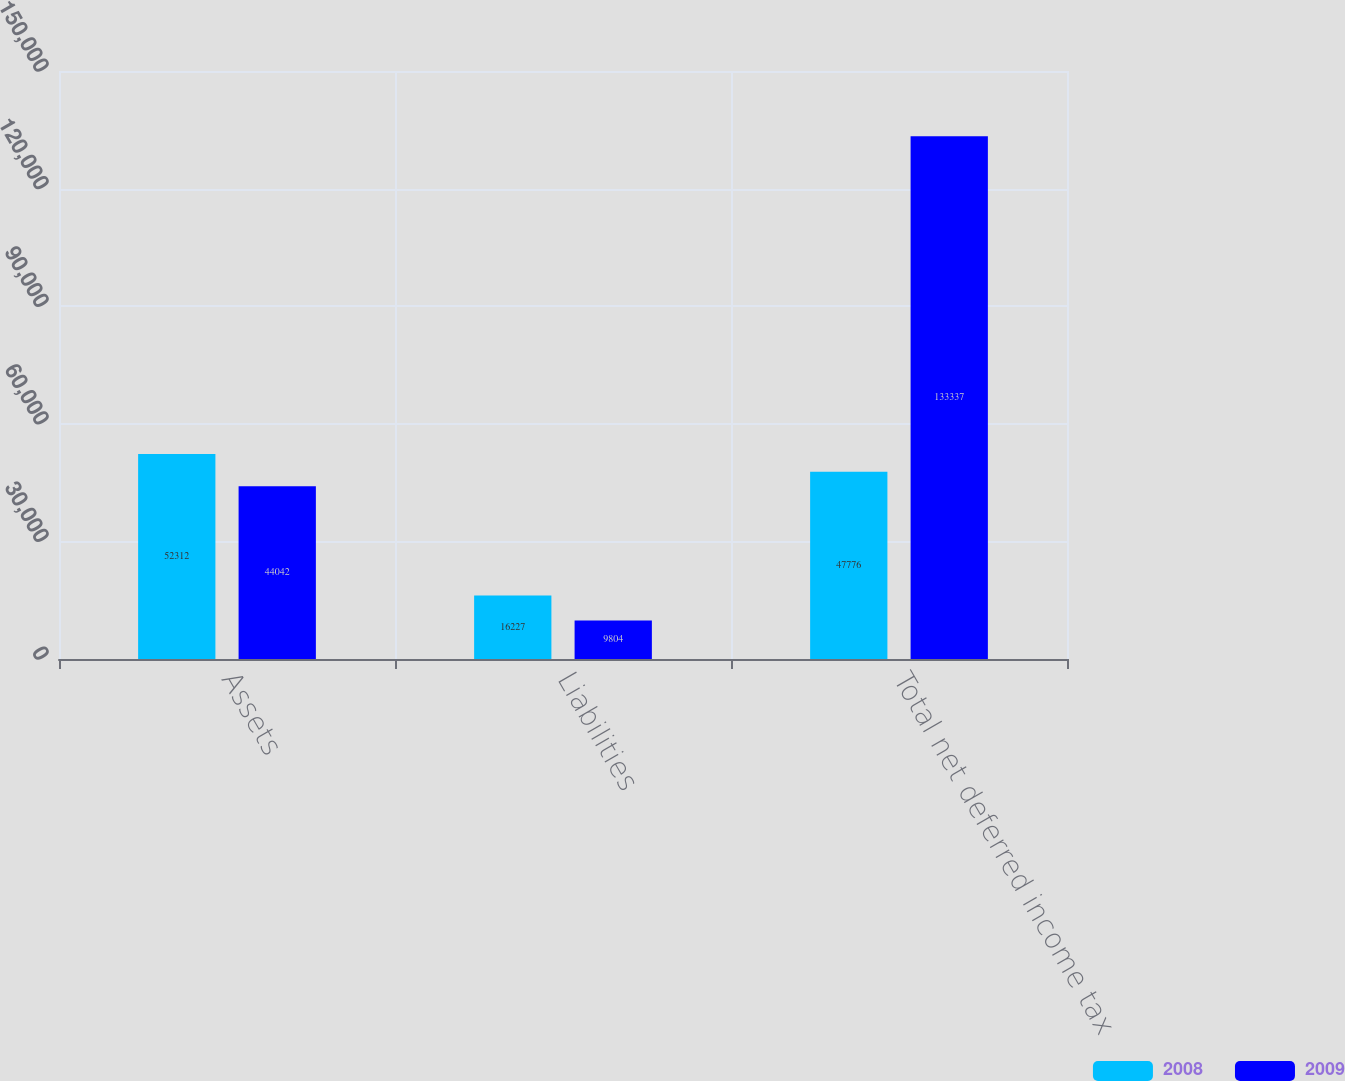Convert chart. <chart><loc_0><loc_0><loc_500><loc_500><stacked_bar_chart><ecel><fcel>Assets<fcel>Liabilities<fcel>Total net deferred income tax<nl><fcel>2008<fcel>52312<fcel>16227<fcel>47776<nl><fcel>2009<fcel>44042<fcel>9804<fcel>133337<nl></chart> 